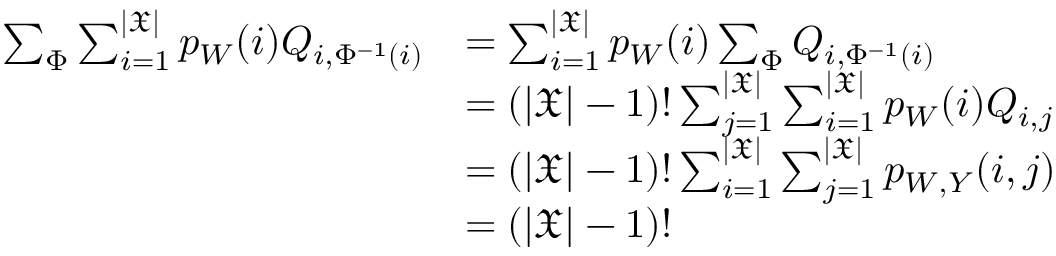Convert formula to latex. <formula><loc_0><loc_0><loc_500><loc_500>\begin{array} { r l } { \sum _ { \Phi } \sum _ { i = 1 } ^ { | \mathfrak { X } | } p _ { W } ( i ) Q _ { i , \Phi ^ { - 1 } ( i ) } } & { = \sum _ { i = 1 } ^ { | \mathfrak { X } | } p _ { W } ( i ) \sum _ { \Phi } Q _ { i , \Phi ^ { - 1 } ( i ) } } \\ & { = ( | \mathfrak { X } | - 1 ) ! \sum _ { j = 1 } ^ { | \mathfrak { X } | } \sum _ { i = 1 } ^ { | \mathfrak { X } | } p _ { W } ( i ) Q _ { i , j } } \\ & { = ( | \mathfrak { X } | - 1 ) ! \sum _ { i = 1 } ^ { | \mathfrak { X } | } \sum _ { j = 1 } ^ { | \mathfrak { X } | } p _ { W , Y } ( i , j ) } \\ & { = ( | \mathfrak { X } | - 1 ) ! } \end{array}</formula> 